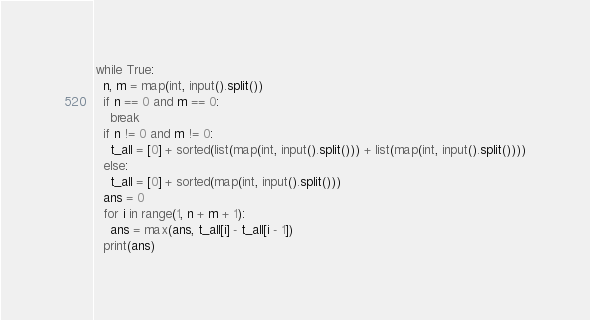Convert code to text. <code><loc_0><loc_0><loc_500><loc_500><_Python_>while True:
  n, m = map(int, input().split())
  if n == 0 and m == 0:
    break
  if n != 0 and m != 0:
    t_all = [0] + sorted(list(map(int, input().split())) + list(map(int, input().split())))
  else:
    t_all = [0] + sorted(map(int, input().split()))
  ans = 0
  for i in range(1, n + m + 1):
    ans = max(ans, t_all[i] - t_all[i - 1])
  print(ans)
</code> 